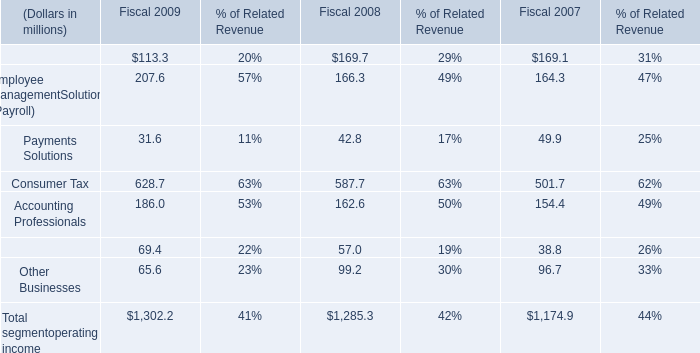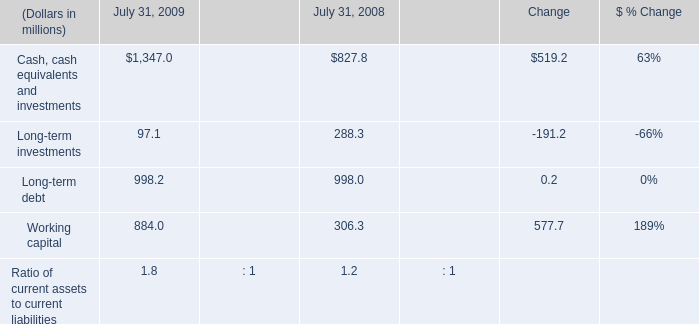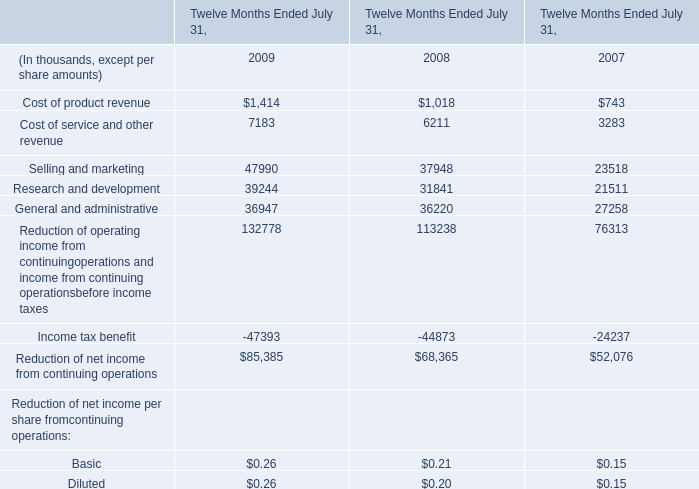What's the sum of Cash, cash equivalents and investments of July 31, 2009, and General and administrative of Twelve Months Ended July 31, 2009 ? 
Computations: (1347.0 + 36947.0)
Answer: 38294.0. 